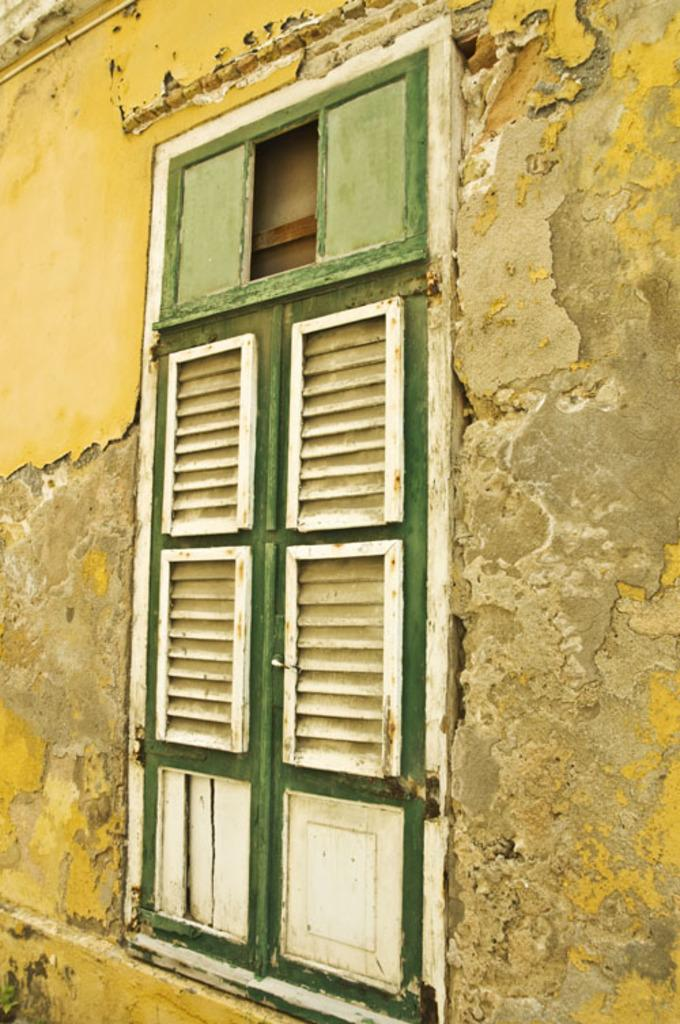What is present in the image? There is a wall in the image. What feature does the wall have? The wall has windows. What colors are the windows? The windows are in green and white color. How many friends can be seen in the image? There are no friends visible in the image; it only features a wall with windows. What type of teeth can be seen in the image? There are no teeth present in the image; it only features a wall with windows. 